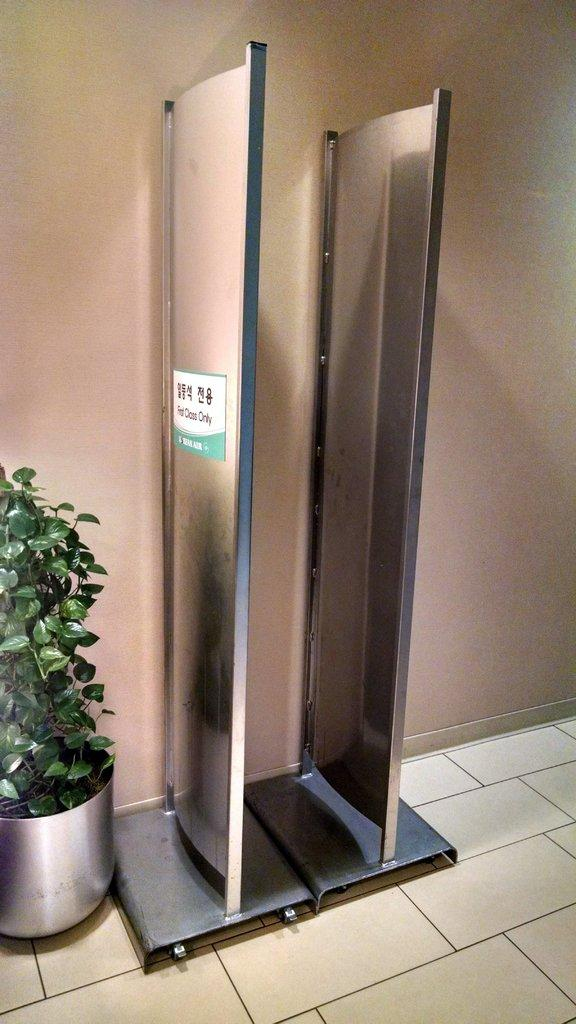What is located in the center of the image? There is a stand in the center of the image. What is placed on the stand? There is a flower pot on the stand. What can be seen in the background of the image? There is a wall in the background of the image. What is visible at the bottom of the image? There is a floor visible at the bottom of the image. What type of poison is being used to water the flowers in the image? There is no poison present in the image; it features a stand with a flower pot on it. How is the string being used in the image? There is no string present in the image. 